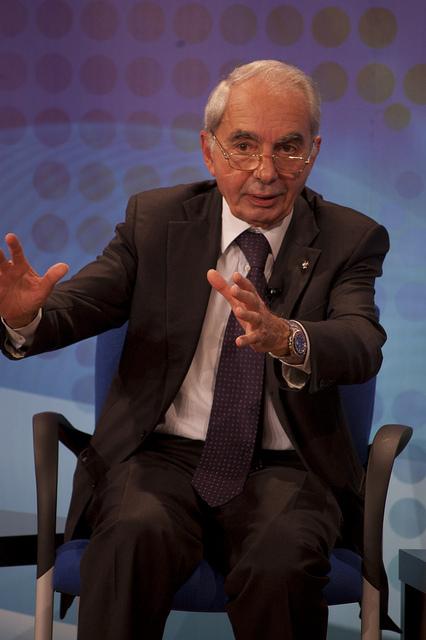Is he clapping?
Short answer required. No. What arm is the man wearing a watch?
Give a very brief answer. Left. What is the man wearing on his face?
Quick response, please. Glasses. 